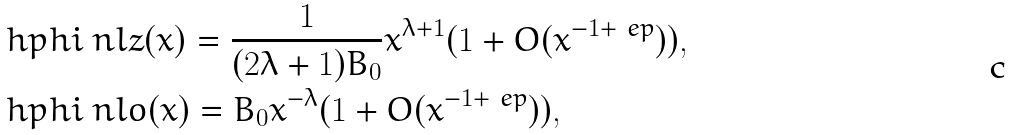Convert formula to latex. <formula><loc_0><loc_0><loc_500><loc_500>& \ h p h i _ { \ } n l z ( x ) = \frac { 1 } { ( 2 \lambda + 1 ) B _ { 0 } } x ^ { \lambda + 1 } ( 1 + O ( x ^ { - 1 + \ e p } ) ) , \\ & \ h p h i _ { \ } n l o ( x ) = B _ { 0 } x ^ { - \lambda } ( 1 + O ( x ^ { - 1 + \ e p } ) ) ,</formula> 